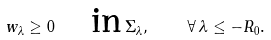Convert formula to latex. <formula><loc_0><loc_0><loc_500><loc_500>w _ { \lambda } \geq 0 \quad \text {in} \, \Sigma _ { \lambda } , \quad \forall \, \lambda \leq - R _ { 0 } .</formula> 